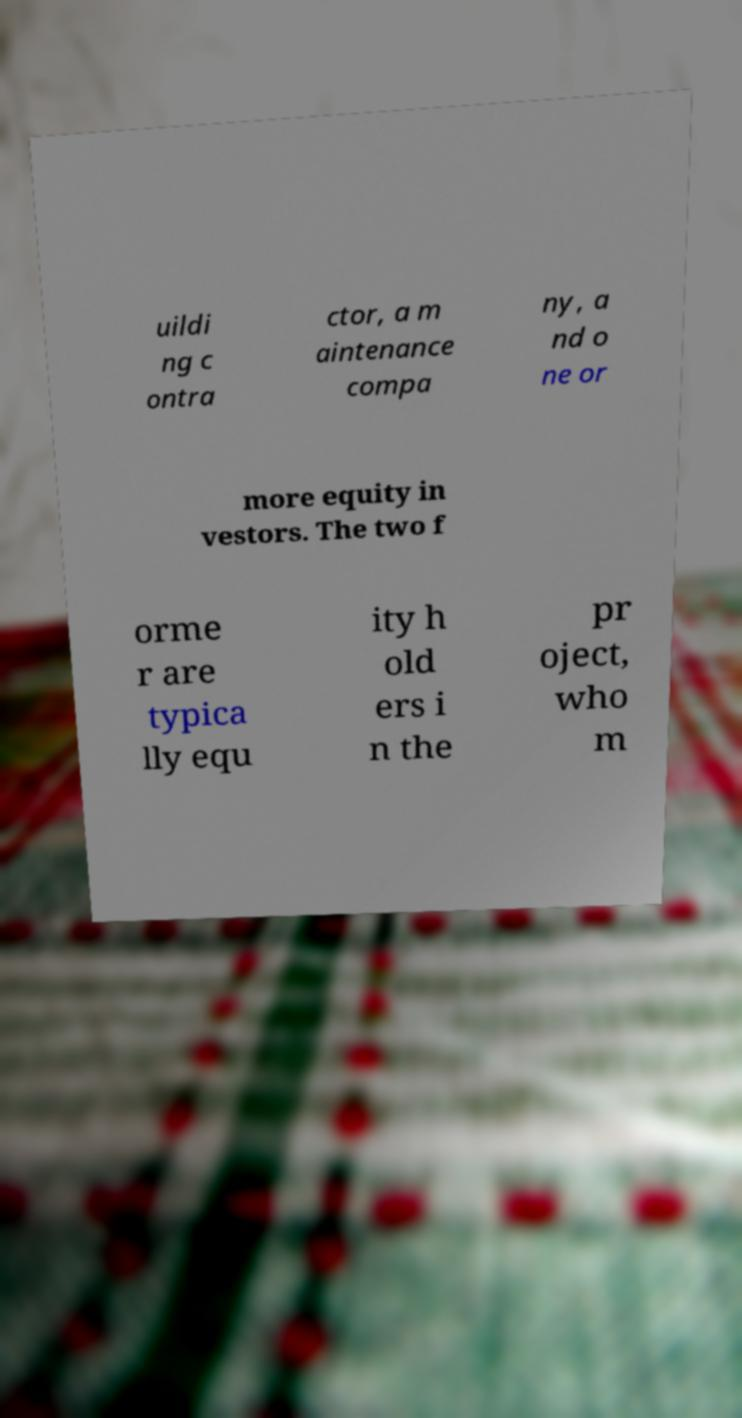For documentation purposes, I need the text within this image transcribed. Could you provide that? uildi ng c ontra ctor, a m aintenance compa ny, a nd o ne or more equity in vestors. The two f orme r are typica lly equ ity h old ers i n the pr oject, who m 